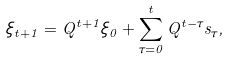<formula> <loc_0><loc_0><loc_500><loc_500>\xi _ { t + 1 } = Q ^ { t + 1 } \xi _ { 0 } + \sum _ { \tau = 0 } ^ { t } Q ^ { t - \tau } s _ { \tau } ,</formula> 